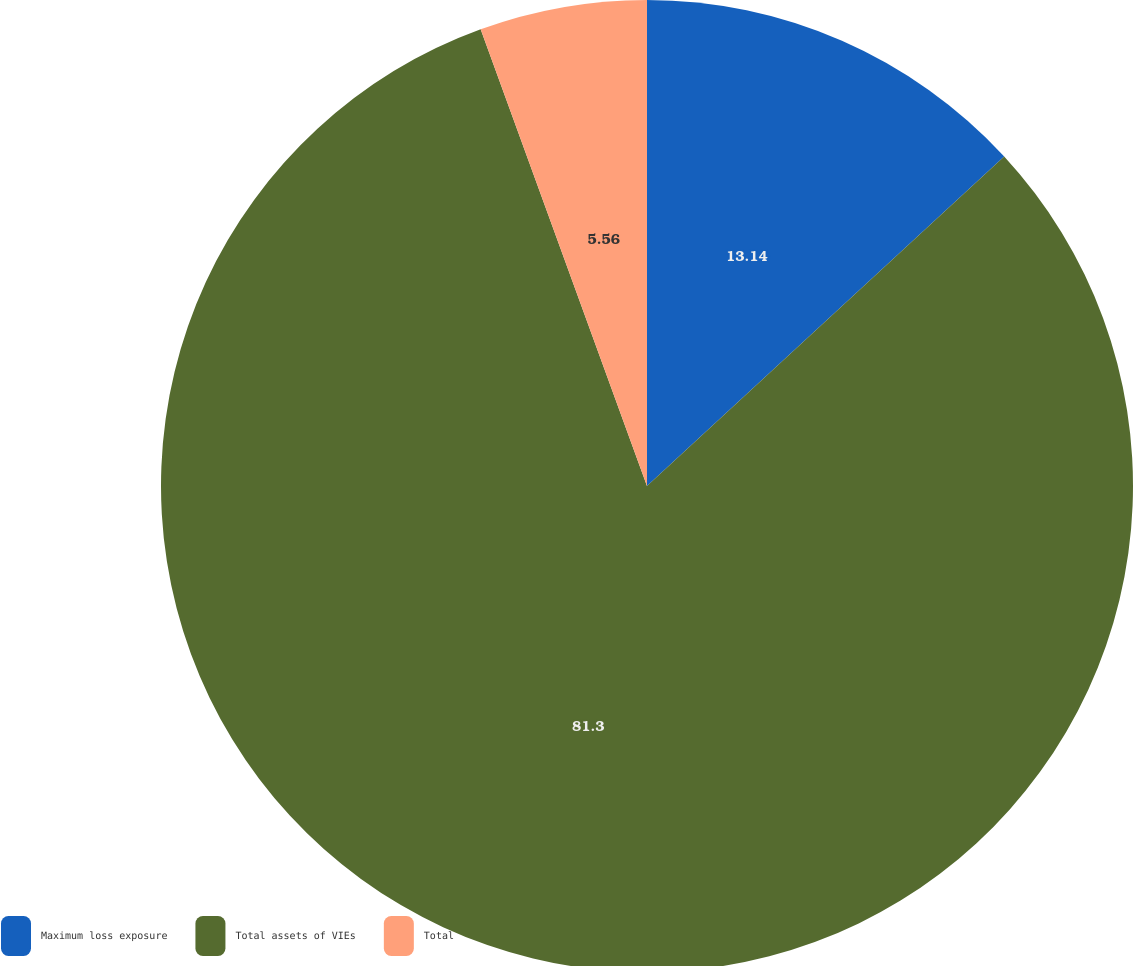<chart> <loc_0><loc_0><loc_500><loc_500><pie_chart><fcel>Maximum loss exposure<fcel>Total assets of VIEs<fcel>Total<nl><fcel>13.14%<fcel>81.3%<fcel>5.56%<nl></chart> 